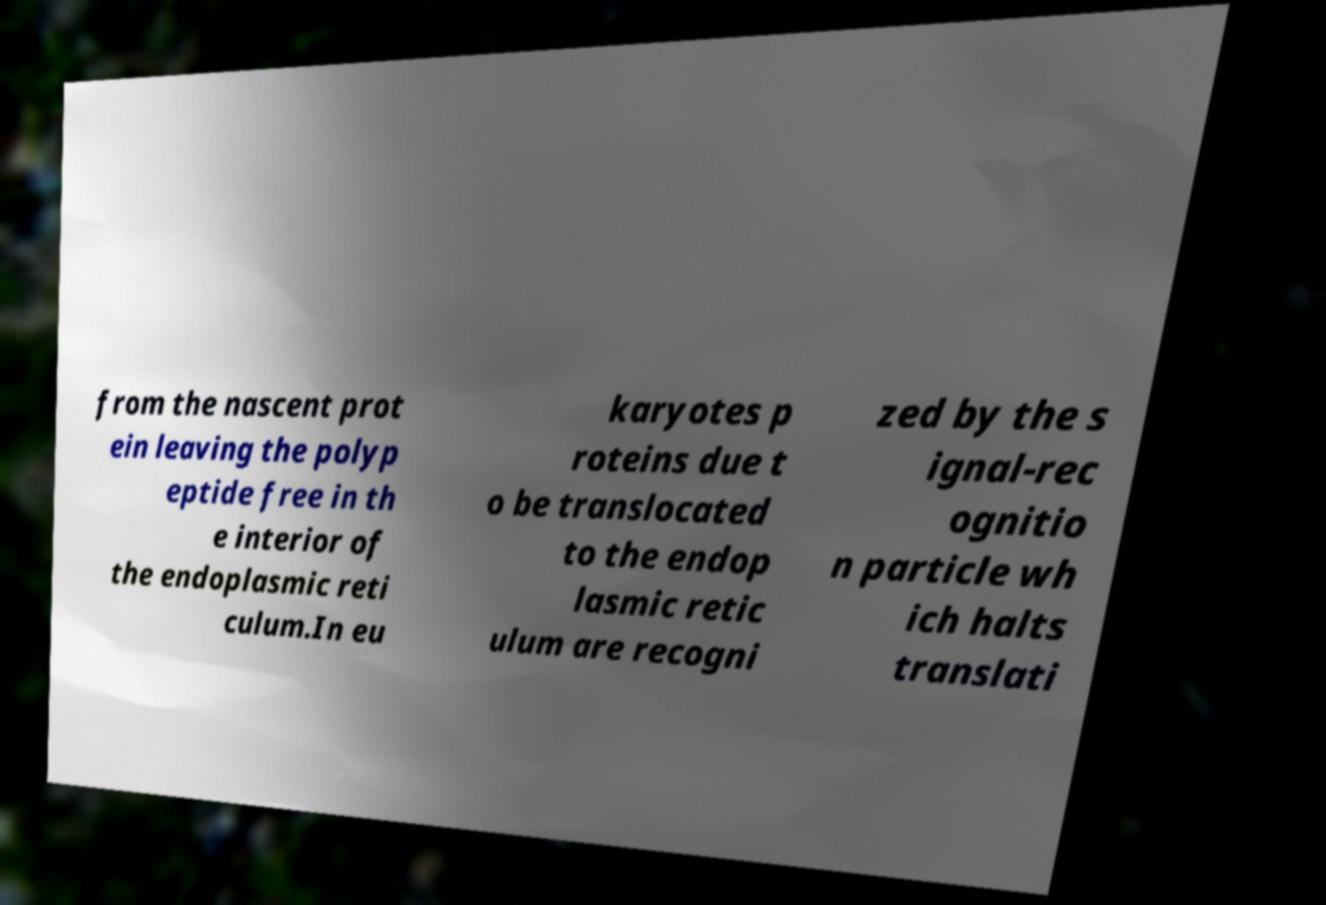There's text embedded in this image that I need extracted. Can you transcribe it verbatim? from the nascent prot ein leaving the polyp eptide free in th e interior of the endoplasmic reti culum.In eu karyotes p roteins due t o be translocated to the endop lasmic retic ulum are recogni zed by the s ignal-rec ognitio n particle wh ich halts translati 